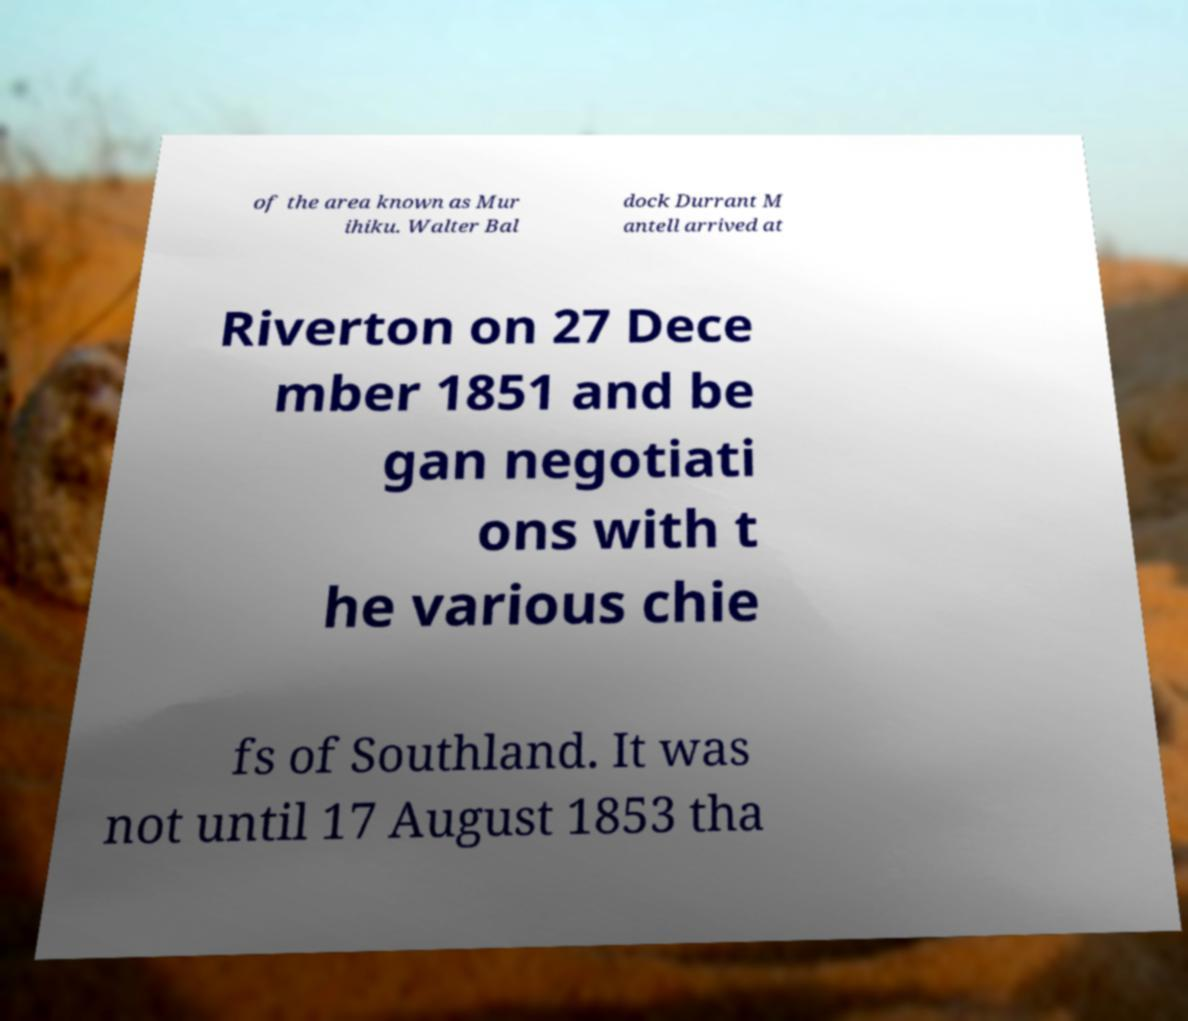Can you read and provide the text displayed in the image?This photo seems to have some interesting text. Can you extract and type it out for me? of the area known as Mur ihiku. Walter Bal dock Durrant M antell arrived at Riverton on 27 Dece mber 1851 and be gan negotiati ons with t he various chie fs of Southland. It was not until 17 August 1853 tha 